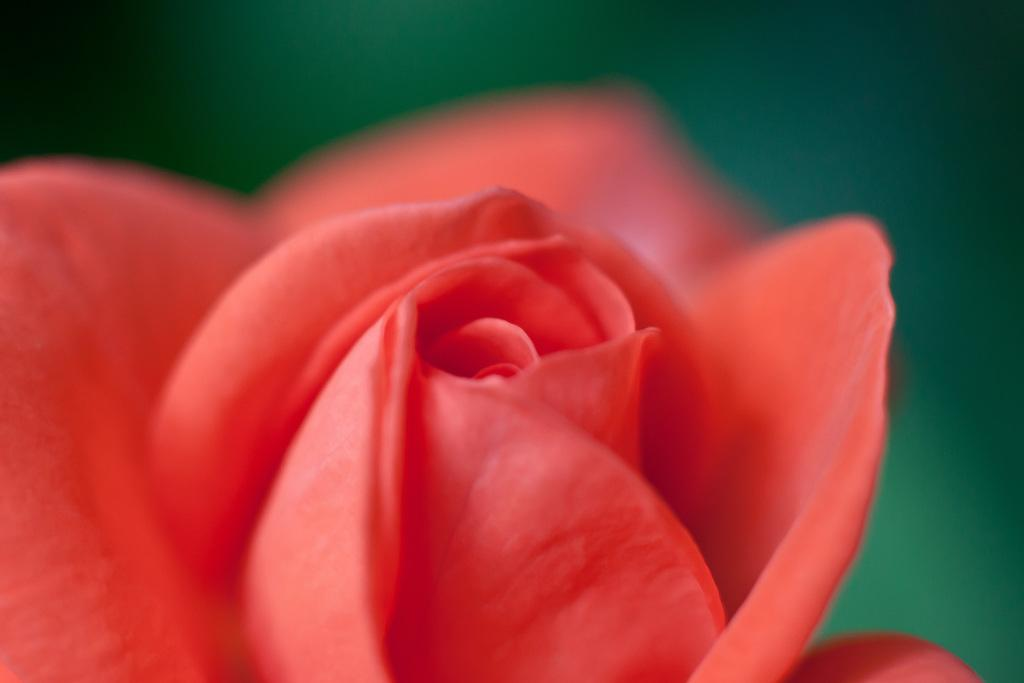What type of flower is in the image? There is an orange rose flower in the image. Can you describe the background of the image? The background of the image is blurry. What type of grass is growing in the army camp in the image? There is no grass or army camp present in the image; it only features an orange rose flower with a blurry background. 